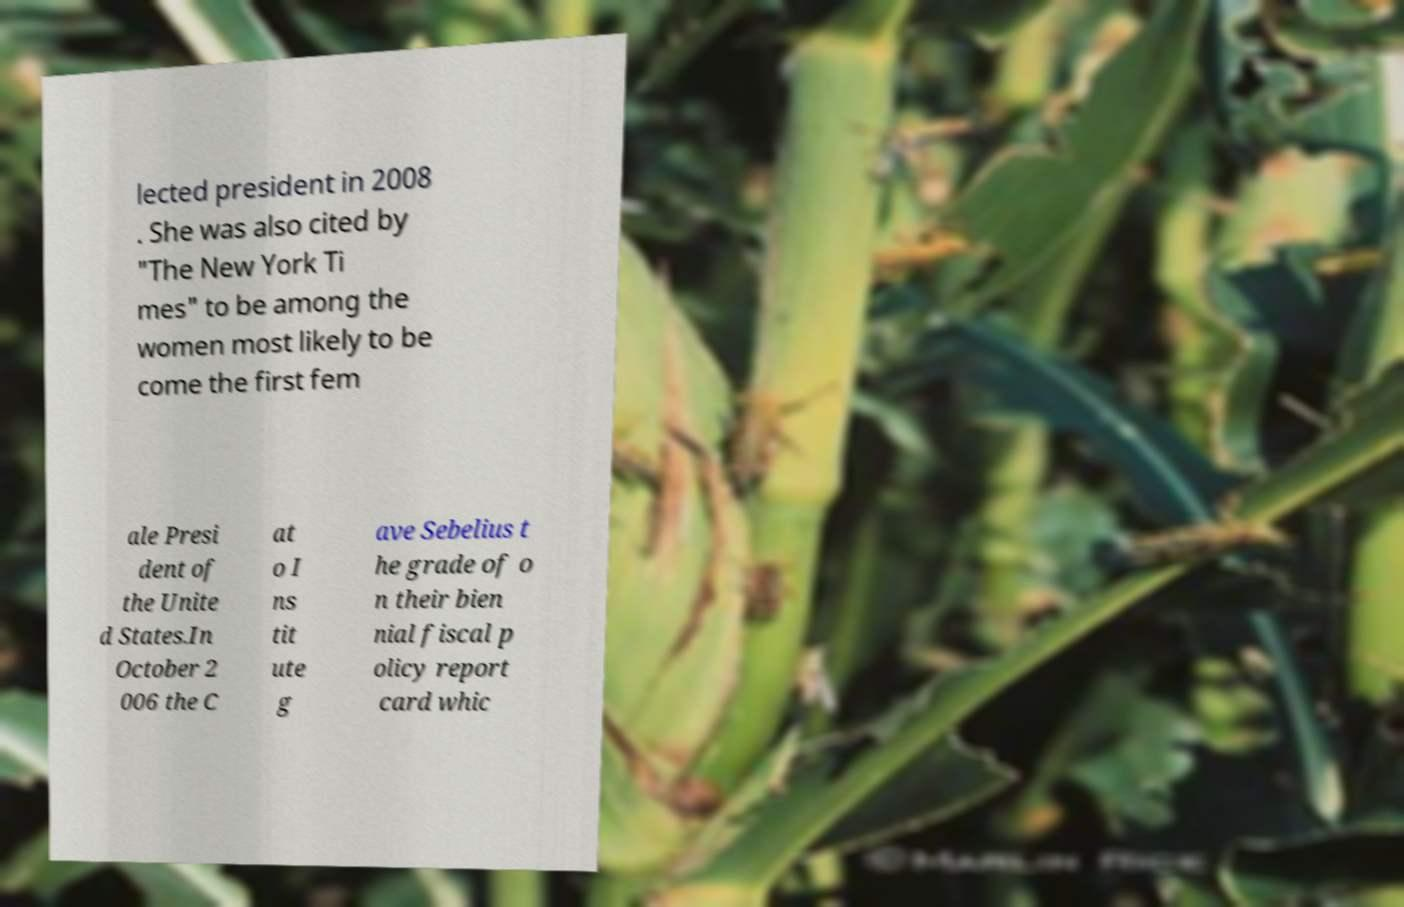What messages or text are displayed in this image? I need them in a readable, typed format. lected president in 2008 . She was also cited by "The New York Ti mes" to be among the women most likely to be come the first fem ale Presi dent of the Unite d States.In October 2 006 the C at o I ns tit ute g ave Sebelius t he grade of o n their bien nial fiscal p olicy report card whic 